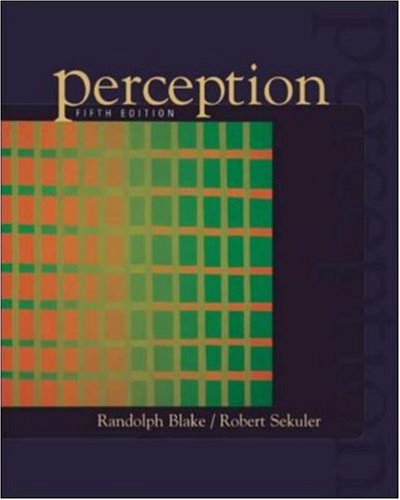Who wrote this book? The book 'Perception' was co-authored by Randolph Blake and Robert Sekuler, both renowned for their contributions to the field of visual perception. 